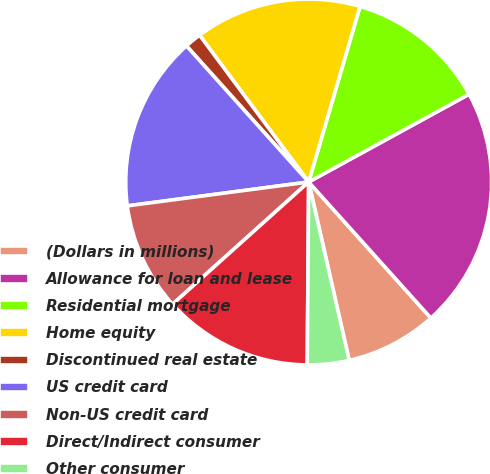Convert chart to OTSL. <chart><loc_0><loc_0><loc_500><loc_500><pie_chart><fcel>(Dollars in millions)<fcel>Allowance for loan and lease<fcel>Residential mortgage<fcel>Home equity<fcel>Discontinued real estate<fcel>US credit card<fcel>Non-US credit card<fcel>Direct/Indirect consumer<fcel>Other consumer<nl><fcel>8.09%<fcel>21.32%<fcel>12.5%<fcel>14.7%<fcel>1.47%<fcel>15.44%<fcel>9.56%<fcel>13.23%<fcel>3.68%<nl></chart> 